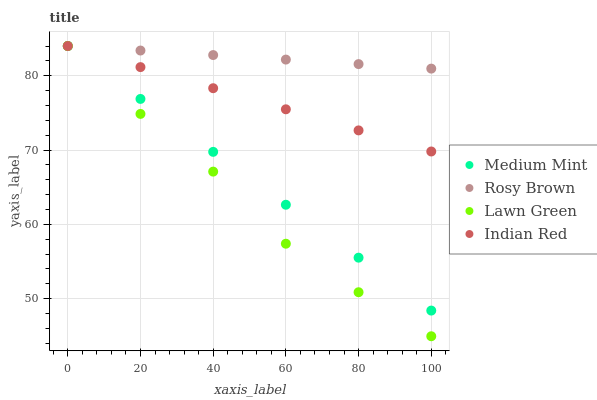Does Lawn Green have the minimum area under the curve?
Answer yes or no. Yes. Does Rosy Brown have the maximum area under the curve?
Answer yes or no. Yes. Does Rosy Brown have the minimum area under the curve?
Answer yes or no. No. Does Lawn Green have the maximum area under the curve?
Answer yes or no. No. Is Medium Mint the smoothest?
Answer yes or no. Yes. Is Lawn Green the roughest?
Answer yes or no. Yes. Is Rosy Brown the smoothest?
Answer yes or no. No. Is Rosy Brown the roughest?
Answer yes or no. No. Does Lawn Green have the lowest value?
Answer yes or no. Yes. Does Rosy Brown have the lowest value?
Answer yes or no. No. Does Indian Red have the highest value?
Answer yes or no. Yes. Does Medium Mint intersect Indian Red?
Answer yes or no. Yes. Is Medium Mint less than Indian Red?
Answer yes or no. No. Is Medium Mint greater than Indian Red?
Answer yes or no. No. 